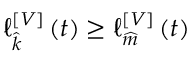Convert formula to latex. <formula><loc_0><loc_0><loc_500><loc_500>_ { \widehat { k } } ^ { \left [ V \right ] } \left ( t \right ) \geq _ { \widehat { m } } ^ { \left [ V \right ] } \left ( t \right )</formula> 